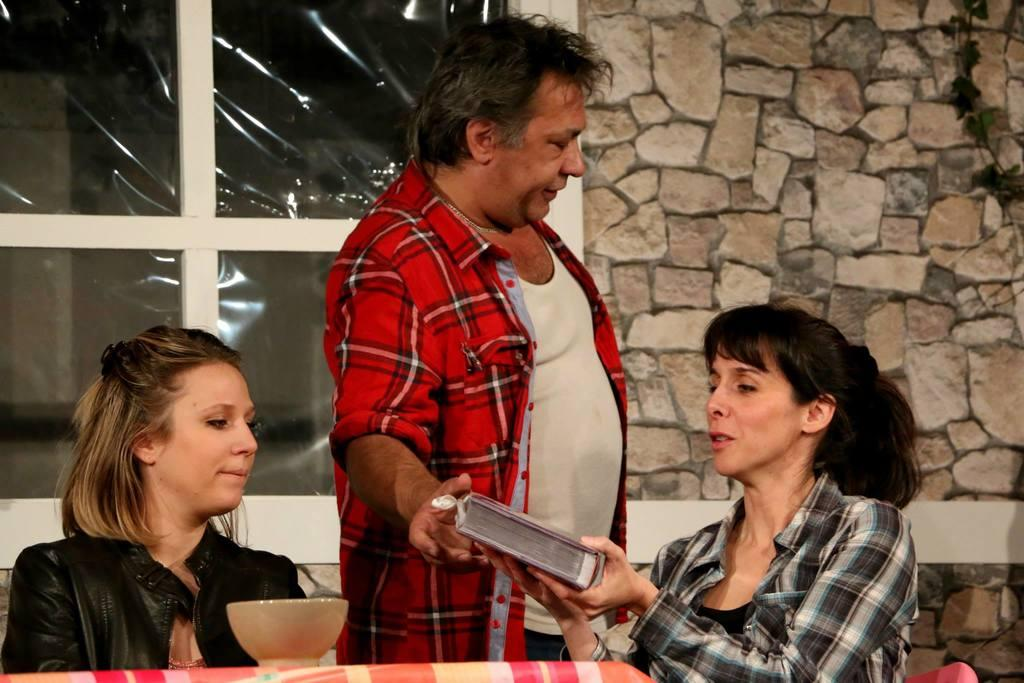How many people are present in the image? There are three people in the image. What is the woman holding in the image? The woman is holding a book. What objects can be seen at the bottom of the image? There is a cloth and a bowl at the bottom of the image. What can be seen in the background of the image? There is a wall and a window in the background of the image. What shapes can be seen on the dolls in the image? There are no dolls present in the image, so there are no shapes to observe on them. What type of bat is flying near the window in the image? There is no bat present in the image; it only features three people, a woman holding a book, a cloth, a bowl, a wall, and a window. 